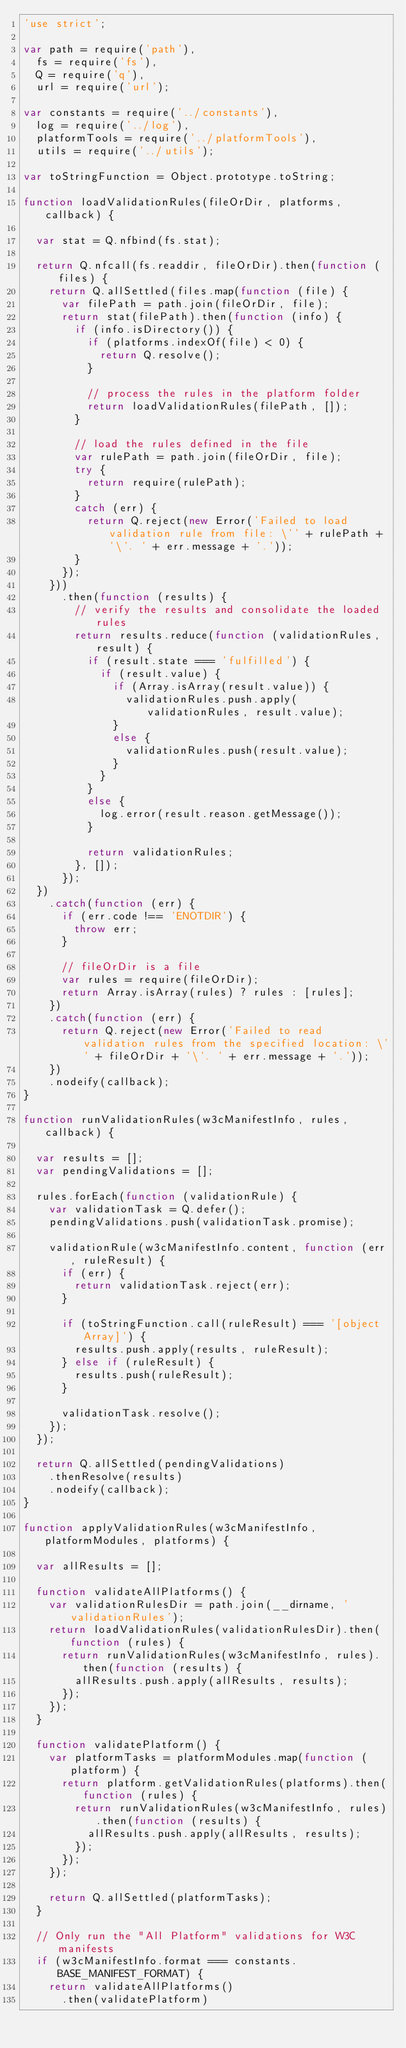Convert code to text. <code><loc_0><loc_0><loc_500><loc_500><_JavaScript_>'use strict';

var path = require('path'),
  fs = require('fs'),
  Q = require('q'),
  url = require('url');

var constants = require('../constants'),
  log = require('../log'),
  platformTools = require('../platformTools'),
  utils = require('../utils');

var toStringFunction = Object.prototype.toString;

function loadValidationRules(fileOrDir, platforms, callback) {

  var stat = Q.nfbind(fs.stat);

  return Q.nfcall(fs.readdir, fileOrDir).then(function (files) {
    return Q.allSettled(files.map(function (file) {
      var filePath = path.join(fileOrDir, file);
      return stat(filePath).then(function (info) {
        if (info.isDirectory()) {
          if (platforms.indexOf(file) < 0) {
            return Q.resolve();
          }
          
          // process the rules in the platform folder
          return loadValidationRules(filePath, []);
        }

        // load the rules defined in the file
        var rulePath = path.join(fileOrDir, file);
        try {
          return require(rulePath);
        }
        catch (err) {
          return Q.reject(new Error('Failed to load validation rule from file: \'' + rulePath + '\'. ' + err.message + '.'));
        }
      });
    }))
      .then(function (results) {
        // verify the results and consolidate the loaded rules  
        return results.reduce(function (validationRules, result) {
          if (result.state === 'fulfilled') {
            if (result.value) {
              if (Array.isArray(result.value)) {
                validationRules.push.apply(validationRules, result.value);
              }
              else {
                validationRules.push(result.value);
              }
            }
          }
          else {
            log.error(result.reason.getMessage());
          }

          return validationRules;
        }, []);
      });
  })
    .catch(function (err) {
      if (err.code !== 'ENOTDIR') {
        throw err;
      }

      // fileOrDir is a file
      var rules = require(fileOrDir);
      return Array.isArray(rules) ? rules : [rules];
    })
    .catch(function (err) {
      return Q.reject(new Error('Failed to read validation rules from the specified location: \'' + fileOrDir + '\'. ' + err.message + '.'));
    })
    .nodeify(callback);
}

function runValidationRules(w3cManifestInfo, rules, callback) {

  var results = [];
  var pendingValidations = [];

  rules.forEach(function (validationRule) {
    var validationTask = Q.defer();
    pendingValidations.push(validationTask.promise);

    validationRule(w3cManifestInfo.content, function (err, ruleResult) {
      if (err) {
        return validationTask.reject(err);
      }

      if (toStringFunction.call(ruleResult) === '[object Array]') {
        results.push.apply(results, ruleResult);
      } else if (ruleResult) {
        results.push(ruleResult);
      }

      validationTask.resolve();
    });
  });

  return Q.allSettled(pendingValidations)
    .thenResolve(results)
    .nodeify(callback);
}

function applyValidationRules(w3cManifestInfo, platformModules, platforms) {

  var allResults = [];

  function validateAllPlatforms() {
    var validationRulesDir = path.join(__dirname, 'validationRules');
    return loadValidationRules(validationRulesDir).then(function (rules) {
      return runValidationRules(w3cManifestInfo, rules).then(function (results) {
        allResults.push.apply(allResults, results);
      });
    });
  }

  function validatePlatform() {
    var platformTasks = platformModules.map(function (platform) {
      return platform.getValidationRules(platforms).then(function (rules) {
        return runValidationRules(w3cManifestInfo, rules).then(function (results) {
          allResults.push.apply(allResults, results);
        });
      });
    });

    return Q.allSettled(platformTasks);
  }

  // Only run the "All Platform" validations for W3C manifests
  if (w3cManifestInfo.format === constants.BASE_MANIFEST_FORMAT) {
    return validateAllPlatforms()
      .then(validatePlatform)</code> 